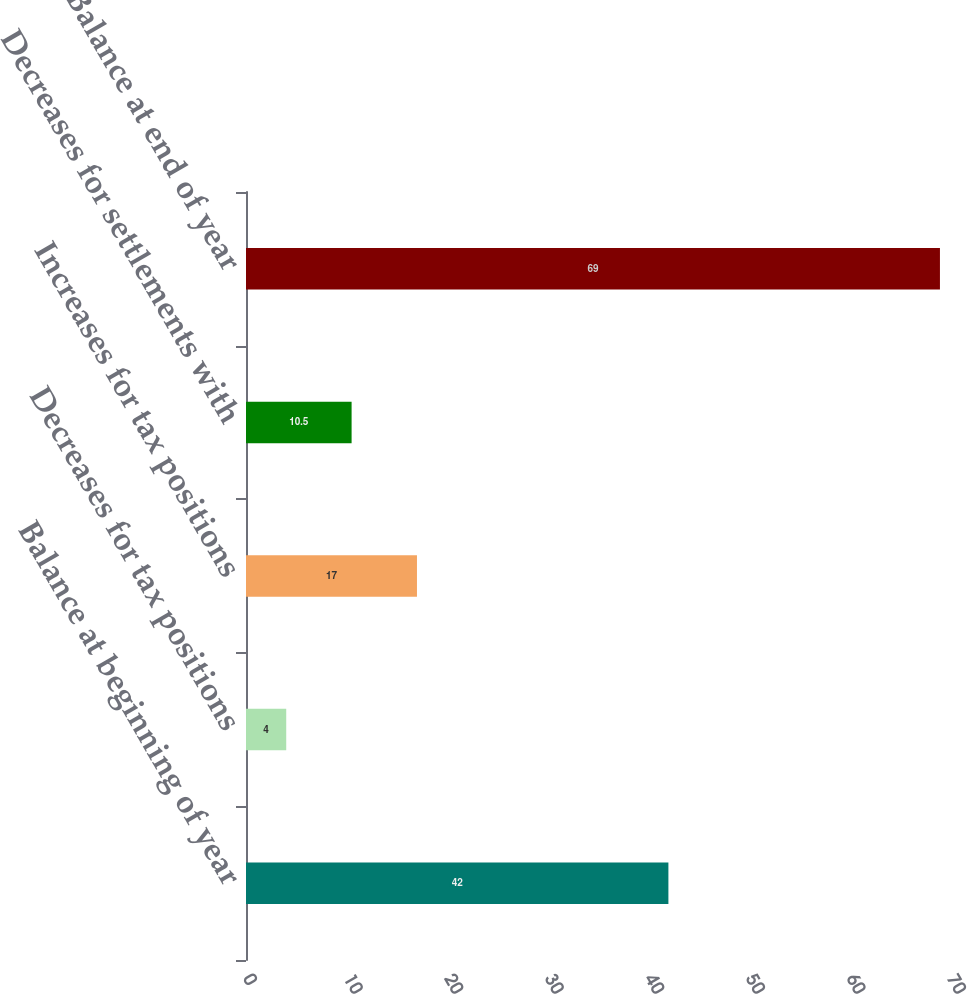Convert chart to OTSL. <chart><loc_0><loc_0><loc_500><loc_500><bar_chart><fcel>Balance at beginning of year<fcel>Decreases for tax positions<fcel>Increases for tax positions<fcel>Decreases for settlements with<fcel>Balance at end of year<nl><fcel>42<fcel>4<fcel>17<fcel>10.5<fcel>69<nl></chart> 